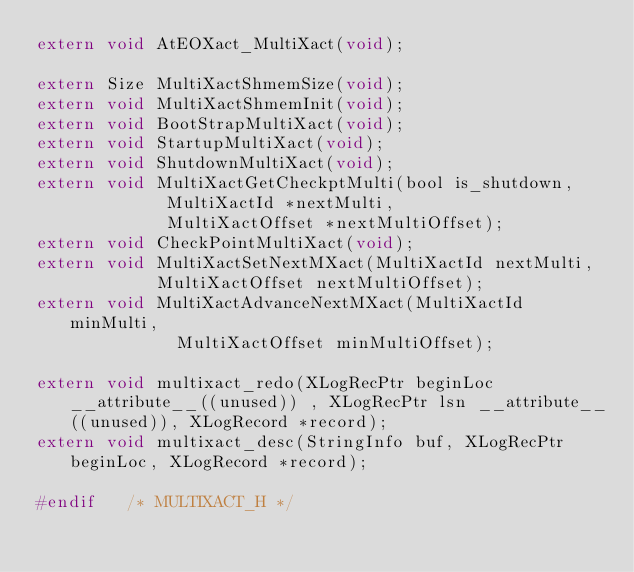<code> <loc_0><loc_0><loc_500><loc_500><_C_>extern void AtEOXact_MultiXact(void);

extern Size MultiXactShmemSize(void);
extern void MultiXactShmemInit(void);
extern void BootStrapMultiXact(void);
extern void StartupMultiXact(void);
extern void ShutdownMultiXact(void);
extern void MultiXactGetCheckptMulti(bool is_shutdown,
						 MultiXactId *nextMulti,
						 MultiXactOffset *nextMultiOffset);
extern void CheckPointMultiXact(void);
extern void MultiXactSetNextMXact(MultiXactId nextMulti,
					  MultiXactOffset nextMultiOffset);
extern void MultiXactAdvanceNextMXact(MultiXactId minMulti,
						  MultiXactOffset minMultiOffset);

extern void multixact_redo(XLogRecPtr beginLoc __attribute__((unused)) , XLogRecPtr lsn __attribute__((unused)), XLogRecord *record);
extern void multixact_desc(StringInfo buf, XLogRecPtr beginLoc, XLogRecord *record);

#endif   /* MULTIXACT_H */
</code> 